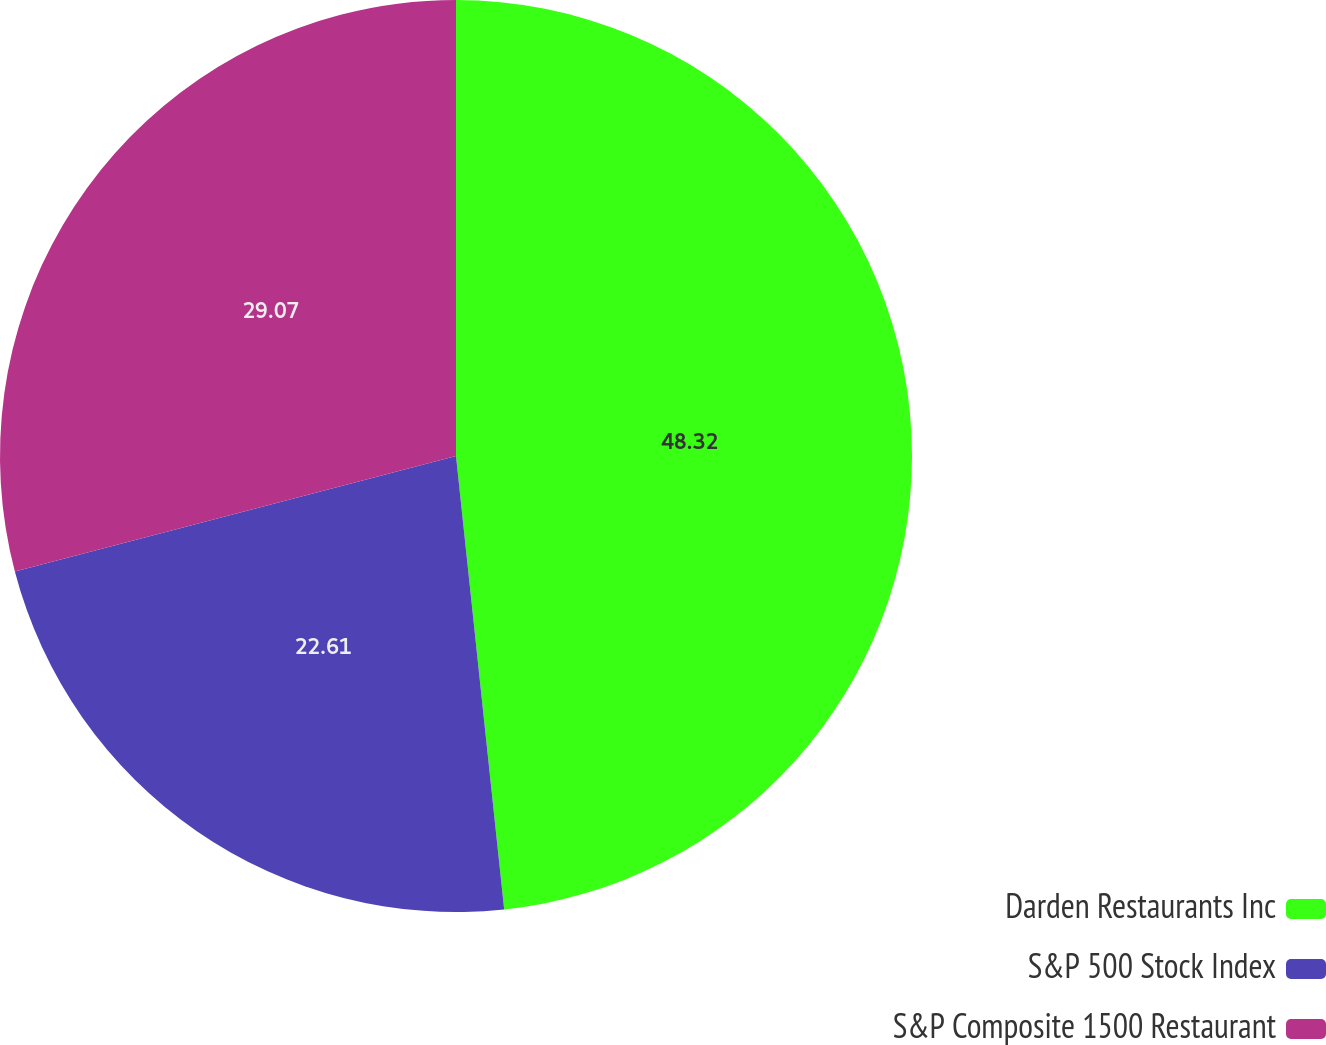Convert chart. <chart><loc_0><loc_0><loc_500><loc_500><pie_chart><fcel>Darden Restaurants Inc<fcel>S&P 500 Stock Index<fcel>S&P Composite 1500 Restaurant<nl><fcel>48.31%<fcel>22.61%<fcel>29.07%<nl></chart> 